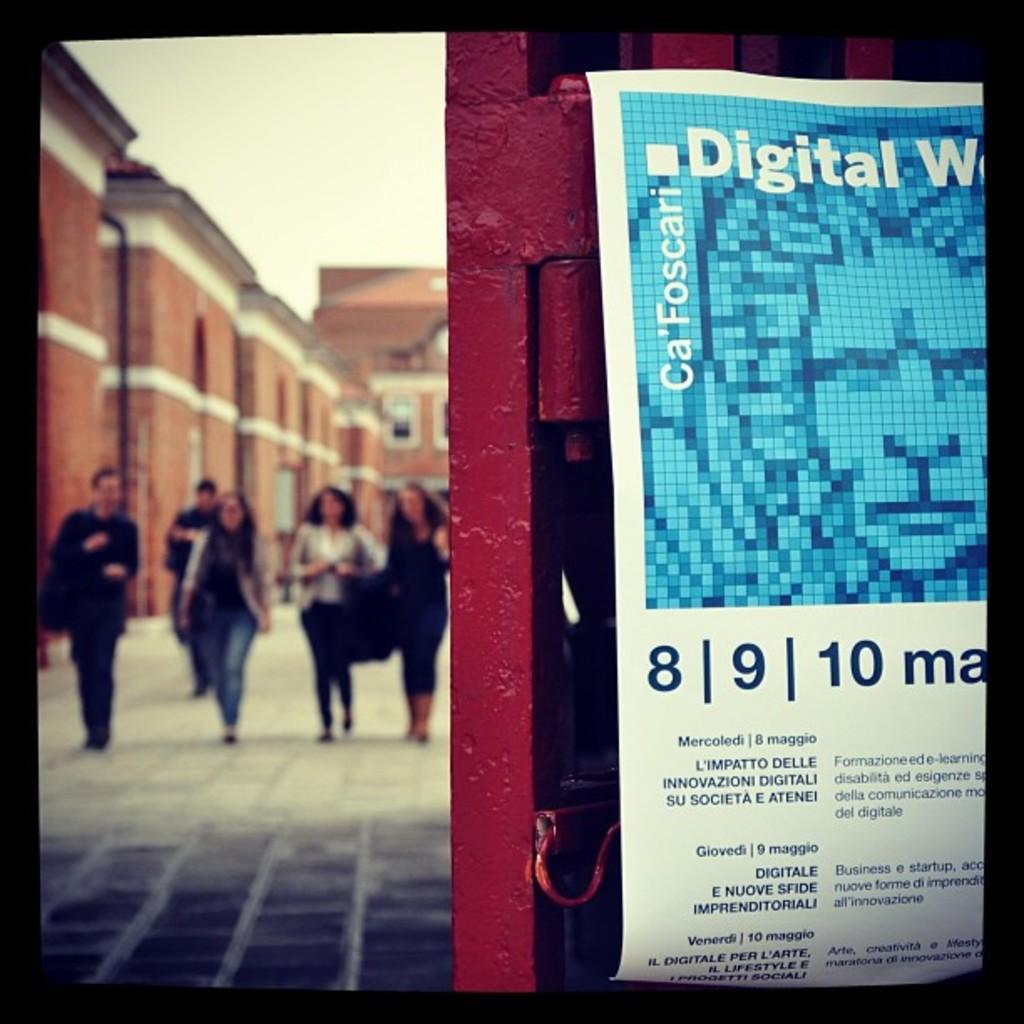How would you summarize this image in a sentence or two? In the image we can see there is a paper poster kept on the gate and there are people standing at the back. Behind there is a building and the image is little blurry at the back. 